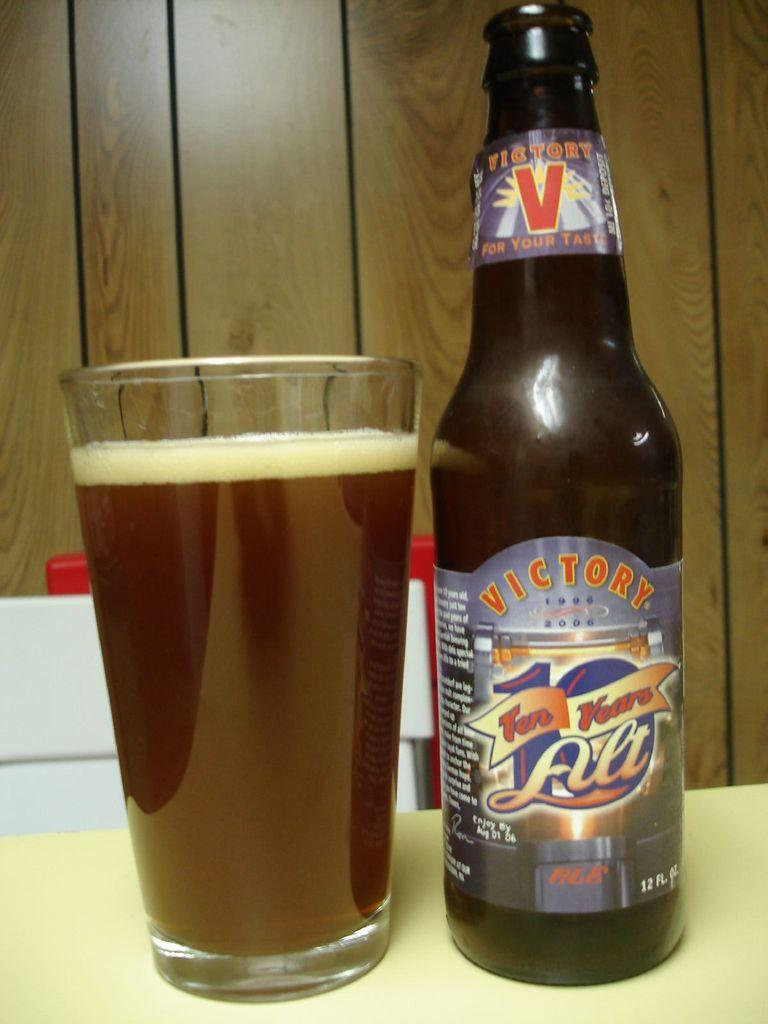Provide a one-sentence caption for the provided image. Bottle of Victory beer next to a full cup of beer. 